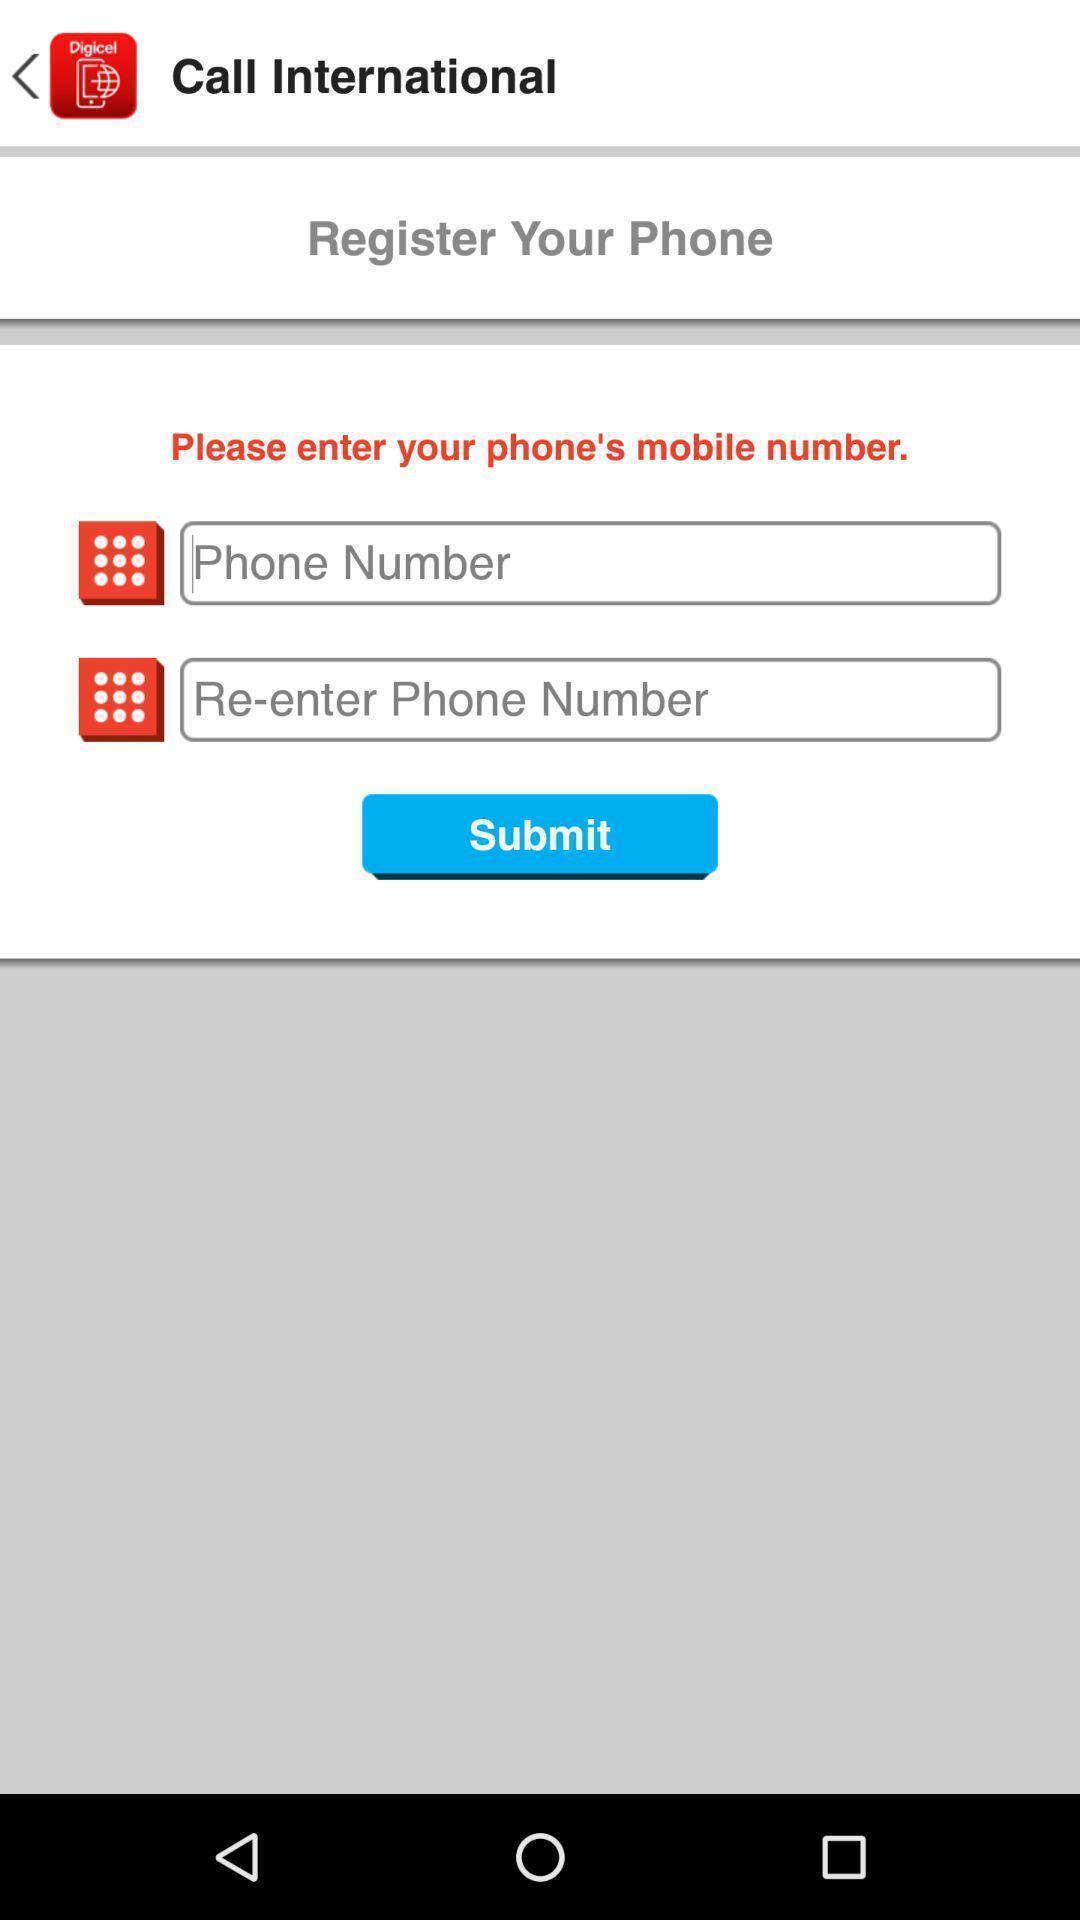What is the overall content of this screenshot? Registration page. 